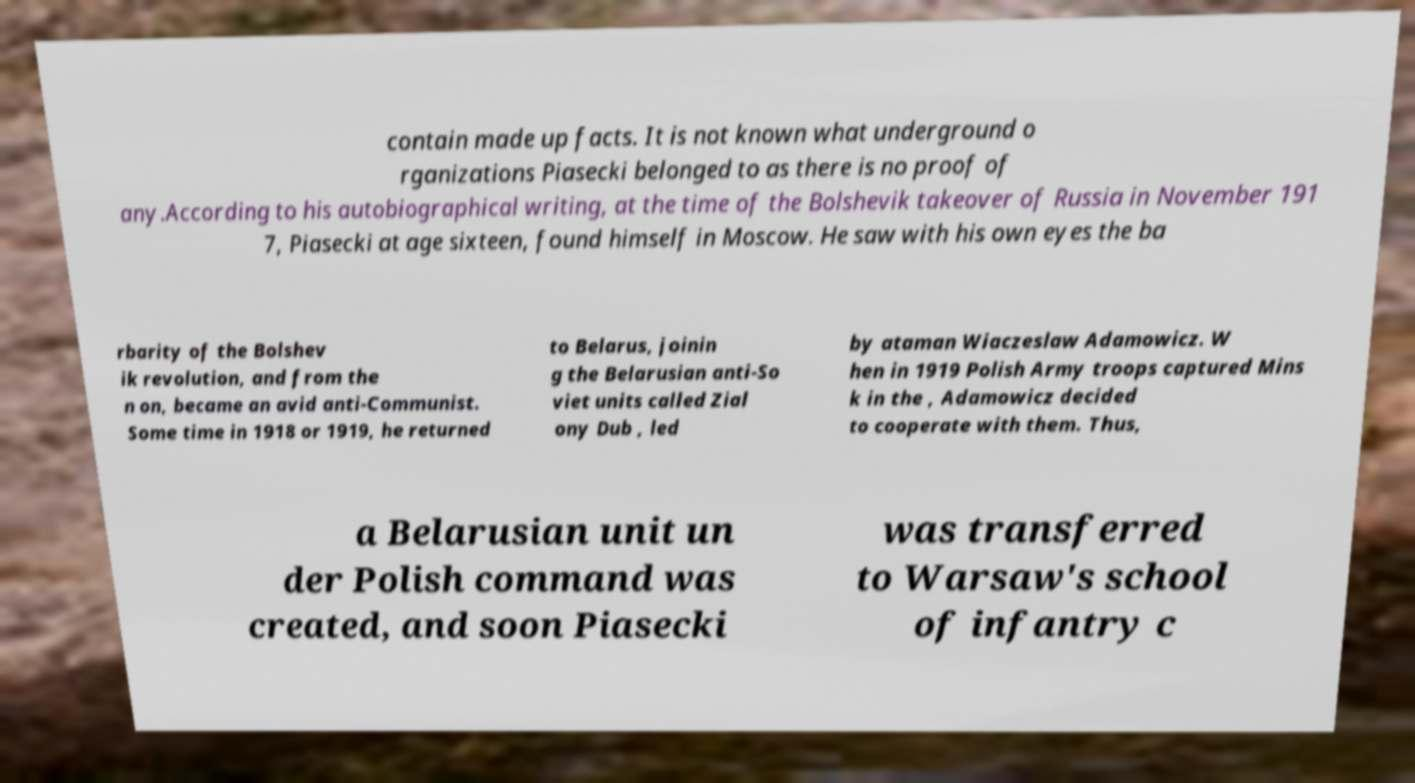Could you extract and type out the text from this image? contain made up facts. It is not known what underground o rganizations Piasecki belonged to as there is no proof of any.According to his autobiographical writing, at the time of the Bolshevik takeover of Russia in November 191 7, Piasecki at age sixteen, found himself in Moscow. He saw with his own eyes the ba rbarity of the Bolshev ik revolution, and from the n on, became an avid anti-Communist. Some time in 1918 or 1919, he returned to Belarus, joinin g the Belarusian anti-So viet units called Zial ony Dub , led by ataman Wiaczeslaw Adamowicz. W hen in 1919 Polish Army troops captured Mins k in the , Adamowicz decided to cooperate with them. Thus, a Belarusian unit un der Polish command was created, and soon Piasecki was transferred to Warsaw's school of infantry c 